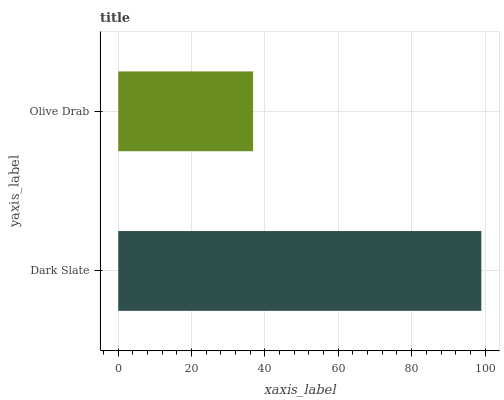Is Olive Drab the minimum?
Answer yes or no. Yes. Is Dark Slate the maximum?
Answer yes or no. Yes. Is Olive Drab the maximum?
Answer yes or no. No. Is Dark Slate greater than Olive Drab?
Answer yes or no. Yes. Is Olive Drab less than Dark Slate?
Answer yes or no. Yes. Is Olive Drab greater than Dark Slate?
Answer yes or no. No. Is Dark Slate less than Olive Drab?
Answer yes or no. No. Is Dark Slate the high median?
Answer yes or no. Yes. Is Olive Drab the low median?
Answer yes or no. Yes. Is Olive Drab the high median?
Answer yes or no. No. Is Dark Slate the low median?
Answer yes or no. No. 